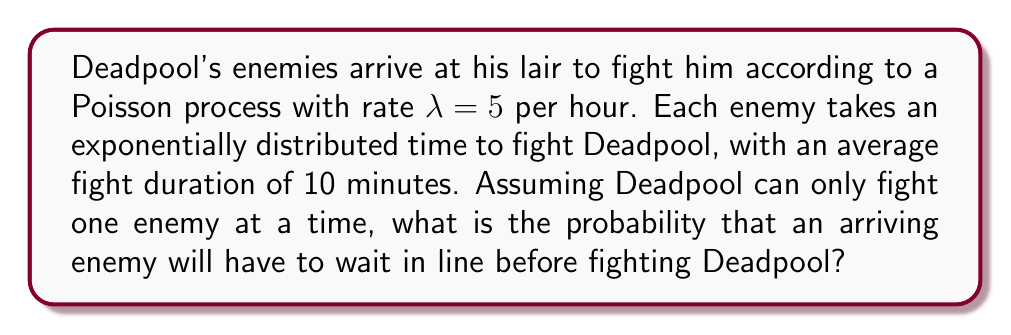Solve this math problem. Let's approach this step-by-step using queueing theory:

1) This scenario describes an M/M/1 queue, where:
   - Arrivals follow a Poisson process (M)
   - Service times are exponentially distributed (M)
   - There is one server (Deadpool)

2) We need to calculate the utilization factor $\rho$:

   $\rho = \frac{\lambda}{\mu}$

   where $\lambda$ is the arrival rate and $\mu$ is the service rate.

3) We have $\lambda = 5$ per hour.

4) To find $\mu$, we need to convert the average fight duration to a rate per hour:
   
   $\mu = \frac{60 \text{ minutes/hour}}{10 \text{ minutes/fight}} = 6 \text{ fights/hour}$

5) Now we can calculate $\rho$:

   $\rho = \frac{5}{6} \approx 0.8333$

6) In an M/M/1 queue, the probability that an arriving customer (enemy) finds the server (Deadpool) busy is equal to $\rho$.

Therefore, the probability that an arriving enemy will have to wait is 0.8333 or about 83.33%.
Answer: $\frac{5}{6} \approx 0.8333$ or 83.33% 